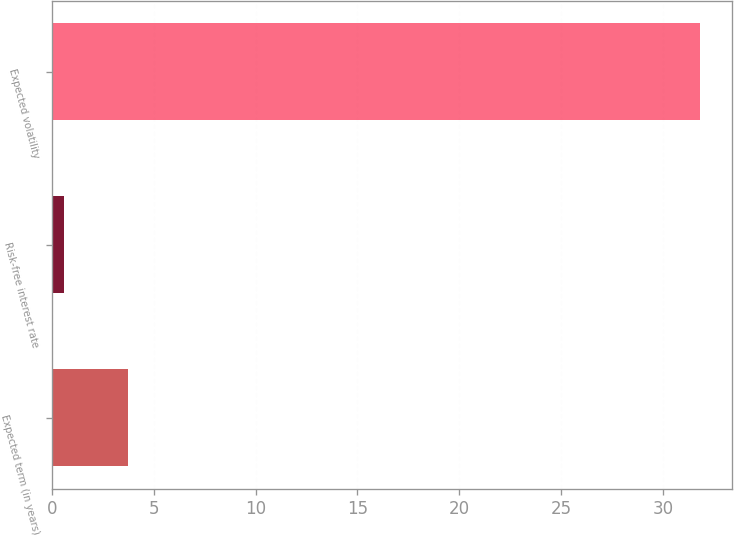Convert chart. <chart><loc_0><loc_0><loc_500><loc_500><bar_chart><fcel>Expected term (in years)<fcel>Risk-free interest rate<fcel>Expected volatility<nl><fcel>3.72<fcel>0.6<fcel>31.8<nl></chart> 